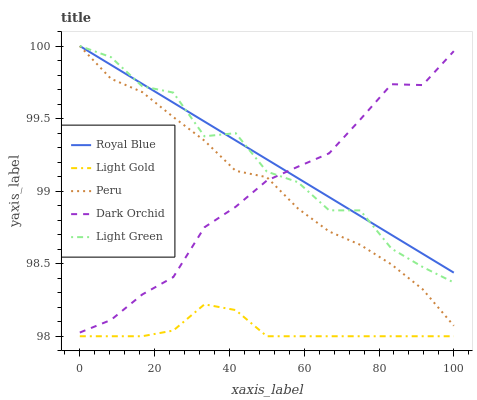Does Light Gold have the minimum area under the curve?
Answer yes or no. Yes. Does Royal Blue have the maximum area under the curve?
Answer yes or no. Yes. Does Light Green have the minimum area under the curve?
Answer yes or no. No. Does Light Green have the maximum area under the curve?
Answer yes or no. No. Is Royal Blue the smoothest?
Answer yes or no. Yes. Is Light Green the roughest?
Answer yes or no. Yes. Is Light Gold the smoothest?
Answer yes or no. No. Is Light Gold the roughest?
Answer yes or no. No. Does Light Gold have the lowest value?
Answer yes or no. Yes. Does Light Green have the lowest value?
Answer yes or no. No. Does Peru have the highest value?
Answer yes or no. Yes. Does Light Gold have the highest value?
Answer yes or no. No. Is Light Gold less than Peru?
Answer yes or no. Yes. Is Peru greater than Light Gold?
Answer yes or no. Yes. Does Peru intersect Dark Orchid?
Answer yes or no. Yes. Is Peru less than Dark Orchid?
Answer yes or no. No. Is Peru greater than Dark Orchid?
Answer yes or no. No. Does Light Gold intersect Peru?
Answer yes or no. No. 